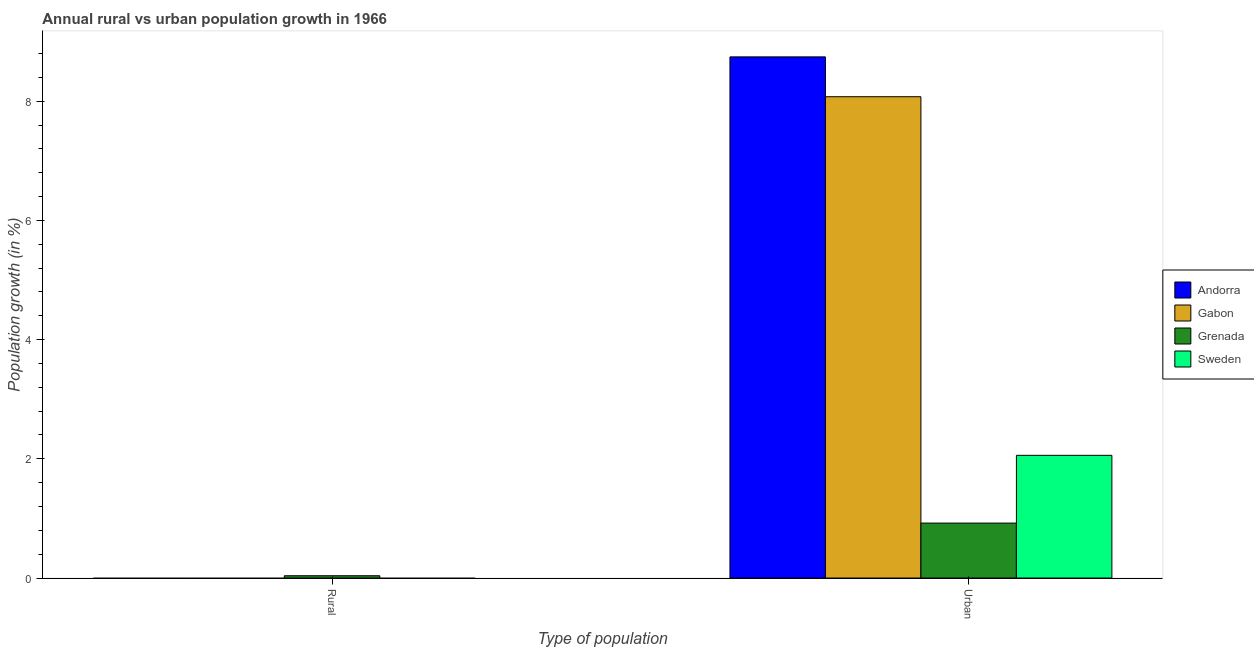How many different coloured bars are there?
Your answer should be compact. 4. Are the number of bars per tick equal to the number of legend labels?
Give a very brief answer. No. How many bars are there on the 2nd tick from the left?
Keep it short and to the point. 4. How many bars are there on the 1st tick from the right?
Give a very brief answer. 4. What is the label of the 1st group of bars from the left?
Give a very brief answer. Rural. What is the urban population growth in Sweden?
Your response must be concise. 2.06. Across all countries, what is the maximum urban population growth?
Keep it short and to the point. 8.74. Across all countries, what is the minimum urban population growth?
Ensure brevity in your answer.  0.92. In which country was the urban population growth maximum?
Offer a very short reply. Andorra. What is the total urban population growth in the graph?
Your response must be concise. 19.8. What is the difference between the urban population growth in Sweden and that in Gabon?
Ensure brevity in your answer.  -6.02. What is the difference between the rural population growth in Grenada and the urban population growth in Sweden?
Ensure brevity in your answer.  -2.02. What is the average rural population growth per country?
Your answer should be compact. 0.01. What is the difference between the urban population growth and rural population growth in Grenada?
Give a very brief answer. 0.88. What is the ratio of the urban population growth in Andorra to that in Gabon?
Ensure brevity in your answer.  1.08. Is the urban population growth in Sweden less than that in Gabon?
Ensure brevity in your answer.  Yes. Are all the bars in the graph horizontal?
Your response must be concise. No. Are the values on the major ticks of Y-axis written in scientific E-notation?
Provide a short and direct response. No. Does the graph contain grids?
Offer a terse response. No. How are the legend labels stacked?
Keep it short and to the point. Vertical. What is the title of the graph?
Give a very brief answer. Annual rural vs urban population growth in 1966. What is the label or title of the X-axis?
Your response must be concise. Type of population. What is the label or title of the Y-axis?
Offer a very short reply. Population growth (in %). What is the Population growth (in %) of Andorra in Rural?
Provide a succinct answer. 0. What is the Population growth (in %) in Gabon in Rural?
Offer a very short reply. 0. What is the Population growth (in %) of Grenada in Rural?
Make the answer very short. 0.04. What is the Population growth (in %) in Sweden in Rural?
Keep it short and to the point. 0. What is the Population growth (in %) in Andorra in Urban ?
Provide a short and direct response. 8.74. What is the Population growth (in %) in Gabon in Urban ?
Your response must be concise. 8.07. What is the Population growth (in %) of Grenada in Urban ?
Your answer should be compact. 0.92. What is the Population growth (in %) of Sweden in Urban ?
Give a very brief answer. 2.06. Across all Type of population, what is the maximum Population growth (in %) in Andorra?
Provide a short and direct response. 8.74. Across all Type of population, what is the maximum Population growth (in %) of Gabon?
Your answer should be very brief. 8.07. Across all Type of population, what is the maximum Population growth (in %) in Grenada?
Offer a terse response. 0.92. Across all Type of population, what is the maximum Population growth (in %) of Sweden?
Keep it short and to the point. 2.06. Across all Type of population, what is the minimum Population growth (in %) of Andorra?
Ensure brevity in your answer.  0. Across all Type of population, what is the minimum Population growth (in %) in Gabon?
Make the answer very short. 0. Across all Type of population, what is the minimum Population growth (in %) of Grenada?
Offer a very short reply. 0.04. What is the total Population growth (in %) of Andorra in the graph?
Offer a terse response. 8.74. What is the total Population growth (in %) of Gabon in the graph?
Your answer should be compact. 8.07. What is the total Population growth (in %) in Grenada in the graph?
Keep it short and to the point. 0.96. What is the total Population growth (in %) of Sweden in the graph?
Your response must be concise. 2.06. What is the difference between the Population growth (in %) of Grenada in Rural and that in Urban ?
Offer a terse response. -0.88. What is the difference between the Population growth (in %) of Grenada in Rural and the Population growth (in %) of Sweden in Urban?
Keep it short and to the point. -2.02. What is the average Population growth (in %) of Andorra per Type of population?
Provide a succinct answer. 4.37. What is the average Population growth (in %) in Gabon per Type of population?
Offer a terse response. 4.04. What is the average Population growth (in %) in Grenada per Type of population?
Offer a terse response. 0.48. What is the average Population growth (in %) in Sweden per Type of population?
Make the answer very short. 1.03. What is the difference between the Population growth (in %) in Andorra and Population growth (in %) in Gabon in Urban ?
Give a very brief answer. 0.67. What is the difference between the Population growth (in %) in Andorra and Population growth (in %) in Grenada in Urban ?
Give a very brief answer. 7.82. What is the difference between the Population growth (in %) of Andorra and Population growth (in %) of Sweden in Urban ?
Make the answer very short. 6.68. What is the difference between the Population growth (in %) in Gabon and Population growth (in %) in Grenada in Urban ?
Offer a terse response. 7.15. What is the difference between the Population growth (in %) of Gabon and Population growth (in %) of Sweden in Urban ?
Your response must be concise. 6.02. What is the difference between the Population growth (in %) in Grenada and Population growth (in %) in Sweden in Urban ?
Provide a short and direct response. -1.14. What is the ratio of the Population growth (in %) of Grenada in Rural to that in Urban ?
Your answer should be very brief. 0.04. What is the difference between the highest and the second highest Population growth (in %) of Grenada?
Provide a short and direct response. 0.88. What is the difference between the highest and the lowest Population growth (in %) in Andorra?
Your response must be concise. 8.74. What is the difference between the highest and the lowest Population growth (in %) in Gabon?
Provide a short and direct response. 8.07. What is the difference between the highest and the lowest Population growth (in %) of Grenada?
Your answer should be compact. 0.88. What is the difference between the highest and the lowest Population growth (in %) of Sweden?
Your answer should be compact. 2.06. 